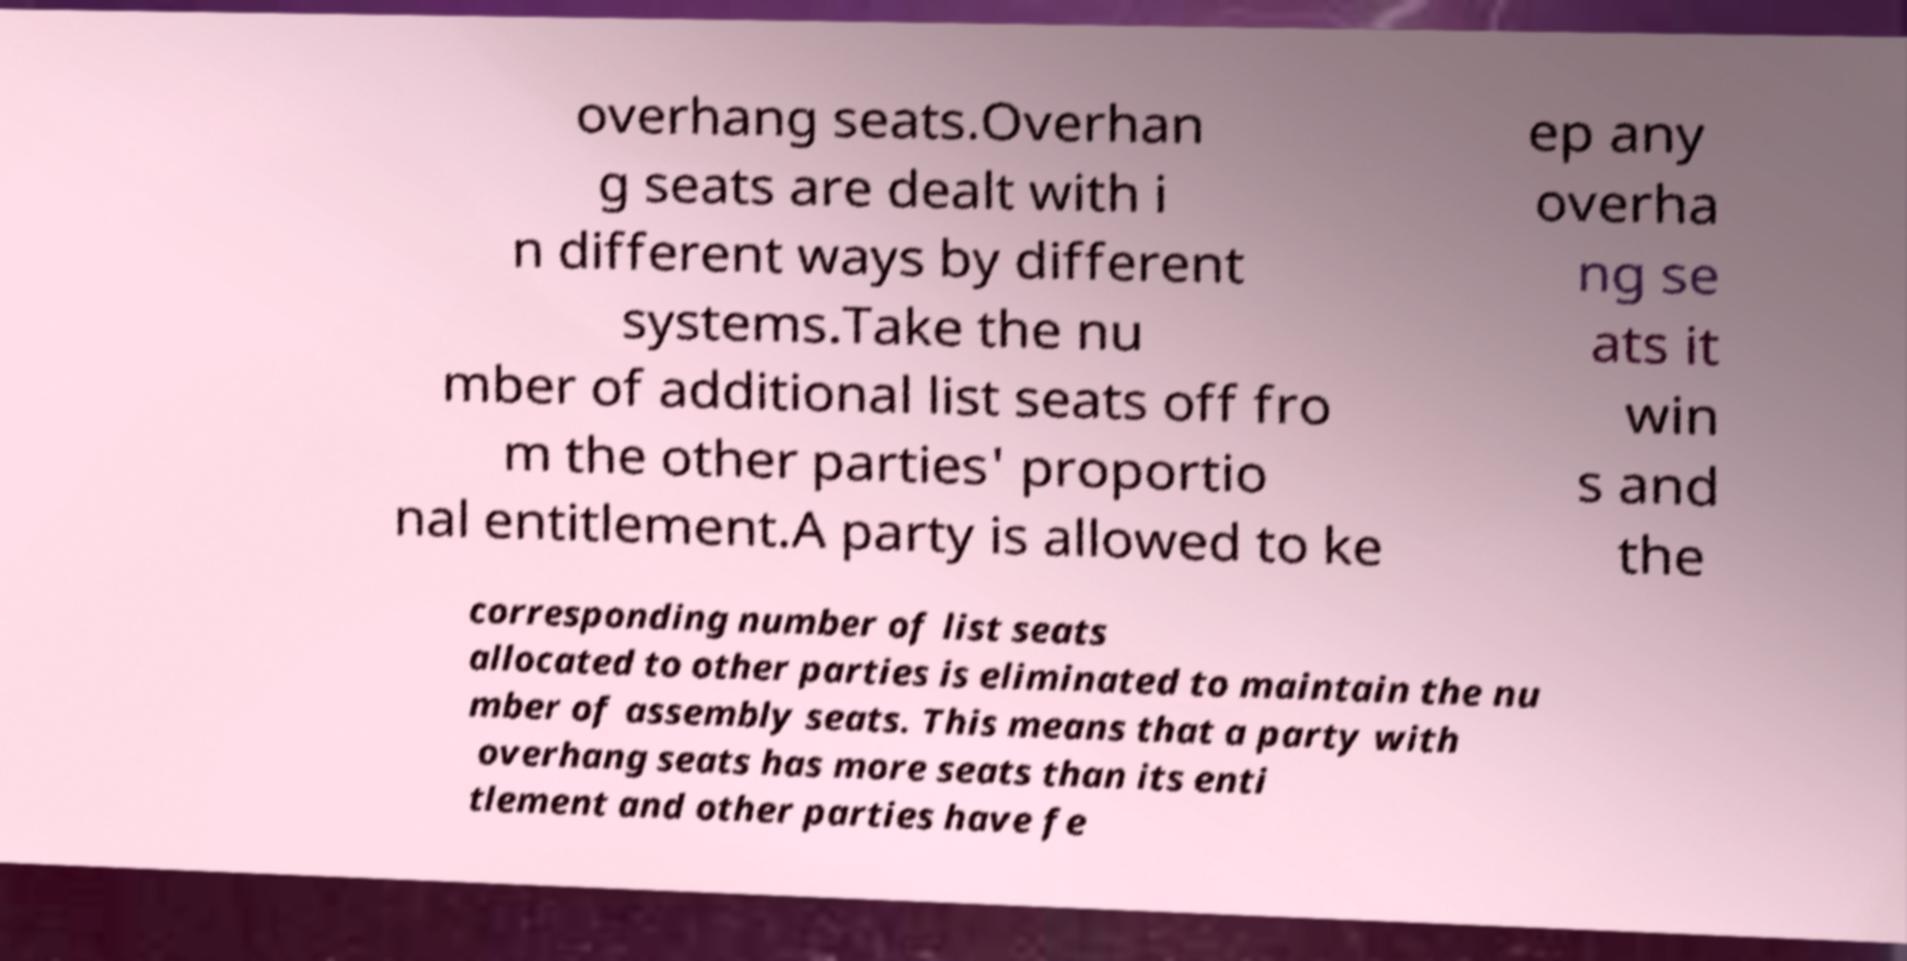Can you accurately transcribe the text from the provided image for me? overhang seats.Overhan g seats are dealt with i n different ways by different systems.Take the nu mber of additional list seats off fro m the other parties' proportio nal entitlement.A party is allowed to ke ep any overha ng se ats it win s and the corresponding number of list seats allocated to other parties is eliminated to maintain the nu mber of assembly seats. This means that a party with overhang seats has more seats than its enti tlement and other parties have fe 